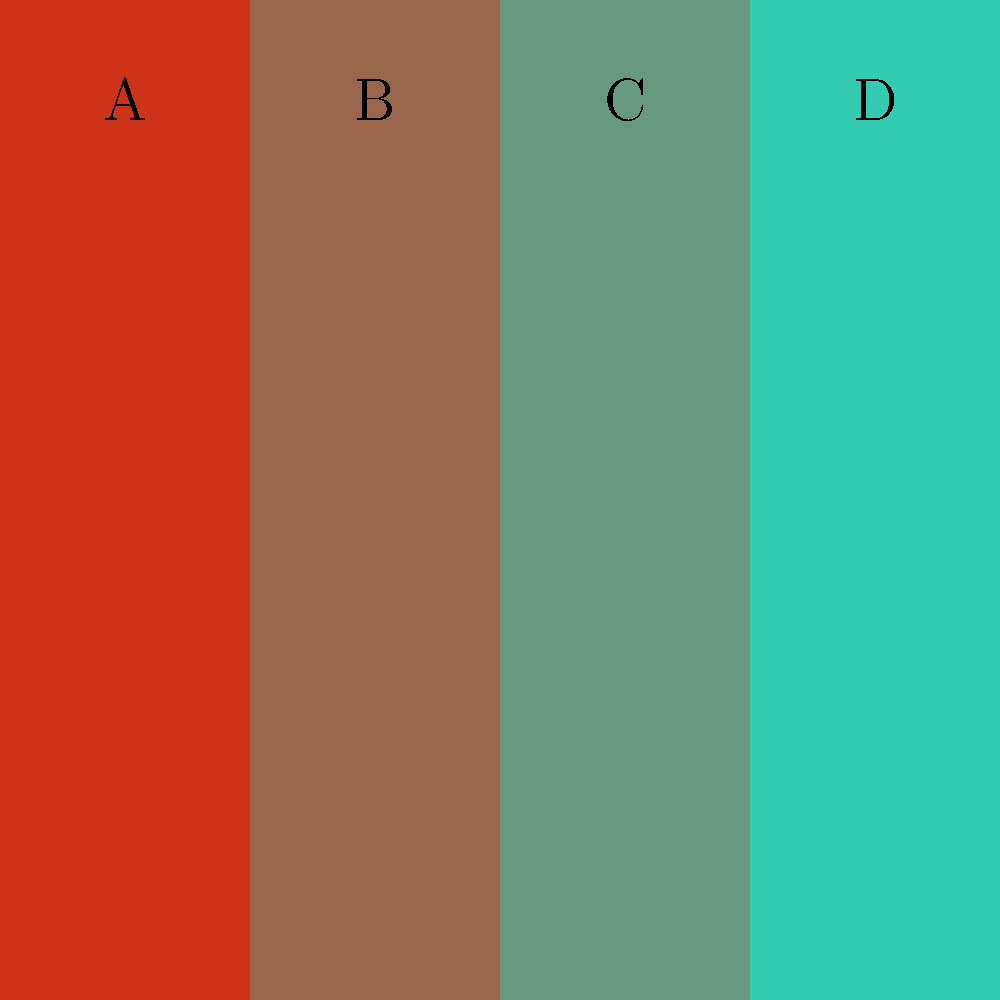In the color palette shown above, which block best represents the dominant hue typically used in warm, cozy interior scenes of Christmas-themed movies like "Christmas in the Smokies"? To answer this question, let's analyze each color block:

1. Block A: This is a deep red color, which is often associated with Christmas themes.
2. Block B: This is a more muted, earthy red-brown tone.
3. Block C: This appears to be a muted green color.
4. Block D: This is a lighter, cooler blue-green shade.

For warm, cozy interior scenes in Christmas-themed movies like "Christmas in the Smokies":

1. Warm colors are typically preferred to create a sense of coziness and comfort.
2. Earthy tones are often used to represent rustic, cabin-like interiors common in movies set in mountain regions like the Smokies.
3. Red is a traditional Christmas color, but a muted version is more likely to be used for large interior areas to avoid overwhelming the scene.

Given these considerations, Block B (the muted, earthy red-brown tone) would be the most appropriate choice for dominant interior color in such scenes. It provides warmth without being too intense, and its earthy quality aligns well with the rustic, mountain setting typical of movies like "Christmas in the Smokies."
Answer: B 